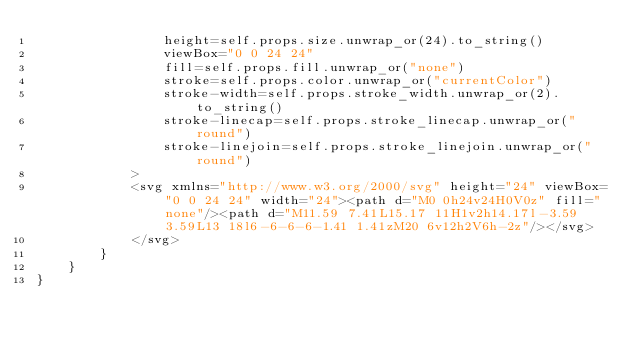Convert code to text. <code><loc_0><loc_0><loc_500><loc_500><_Rust_>                height=self.props.size.unwrap_or(24).to_string()
                viewBox="0 0 24 24"
                fill=self.props.fill.unwrap_or("none")
                stroke=self.props.color.unwrap_or("currentColor")
                stroke-width=self.props.stroke_width.unwrap_or(2).to_string()
                stroke-linecap=self.props.stroke_linecap.unwrap_or("round")
                stroke-linejoin=self.props.stroke_linejoin.unwrap_or("round")
            >
            <svg xmlns="http://www.w3.org/2000/svg" height="24" viewBox="0 0 24 24" width="24"><path d="M0 0h24v24H0V0z" fill="none"/><path d="M11.59 7.41L15.17 11H1v2h14.17l-3.59 3.59L13 18l6-6-6-6-1.41 1.41zM20 6v12h2V6h-2z"/></svg>
            </svg>
        }
    }
}


</code> 